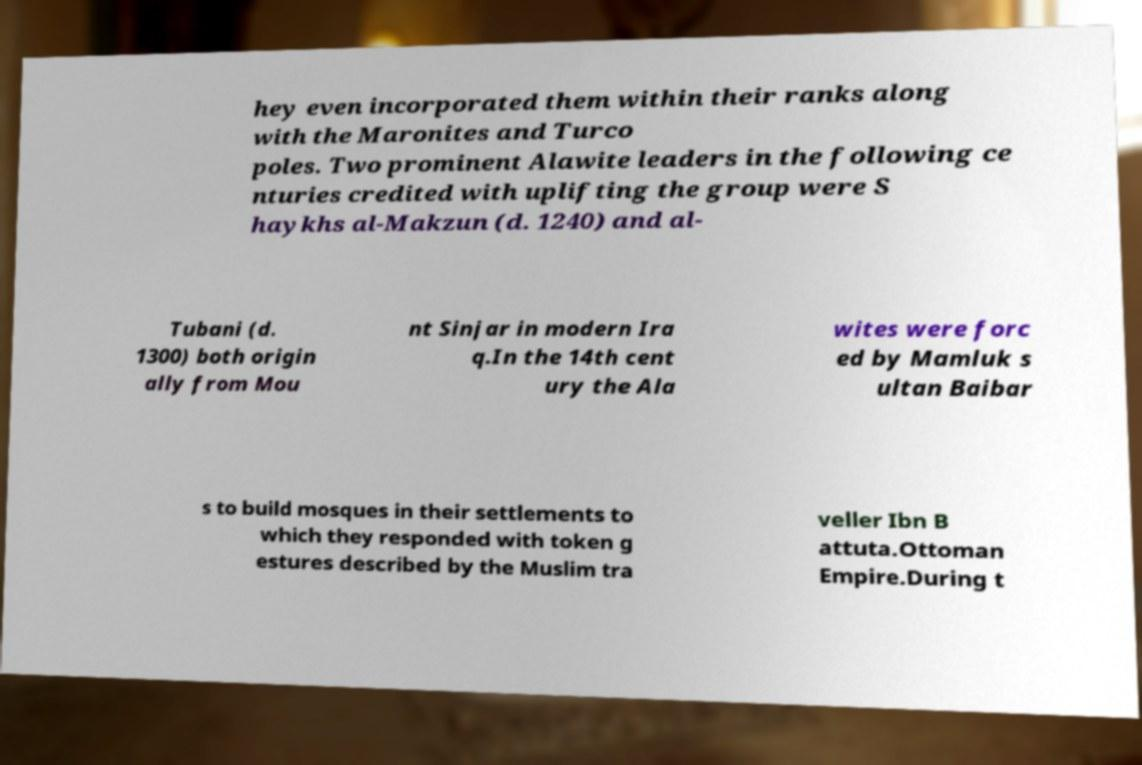Could you extract and type out the text from this image? hey even incorporated them within their ranks along with the Maronites and Turco poles. Two prominent Alawite leaders in the following ce nturies credited with uplifting the group were S haykhs al-Makzun (d. 1240) and al- Tubani (d. 1300) both origin ally from Mou nt Sinjar in modern Ira q.In the 14th cent ury the Ala wites were forc ed by Mamluk s ultan Baibar s to build mosques in their settlements to which they responded with token g estures described by the Muslim tra veller Ibn B attuta.Ottoman Empire.During t 